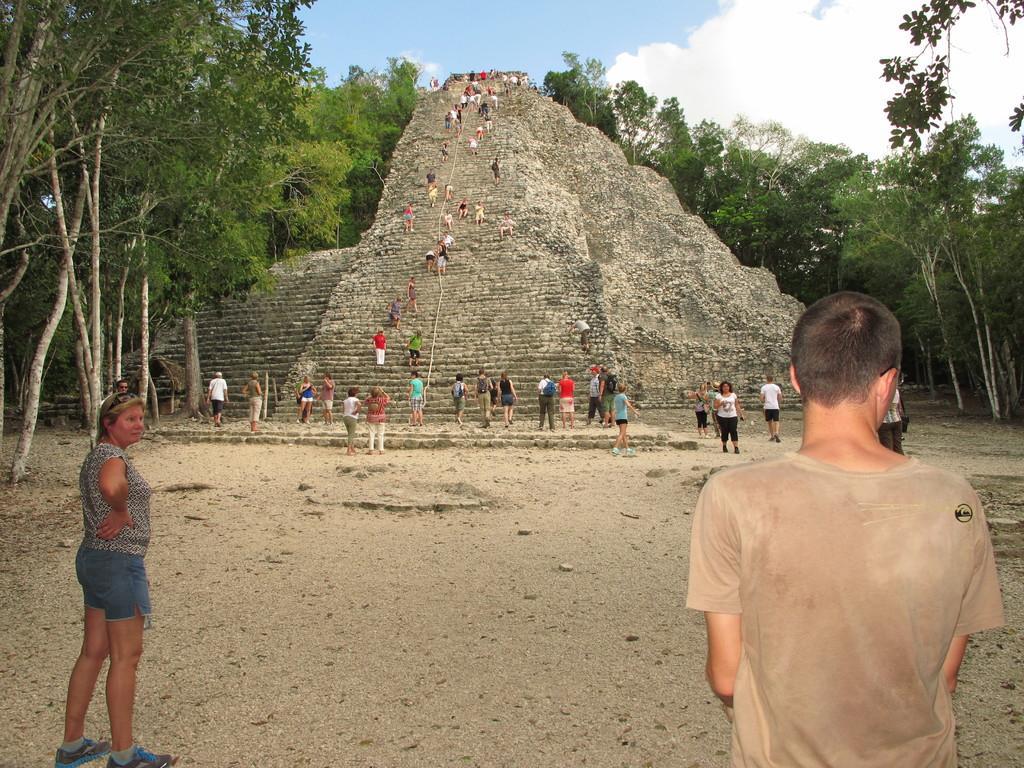Describe this image in one or two sentences. In this image we can see some people and there is the pyramid in the middle and we can see some people are walking. We can also see some trees and the sky with clouds. 